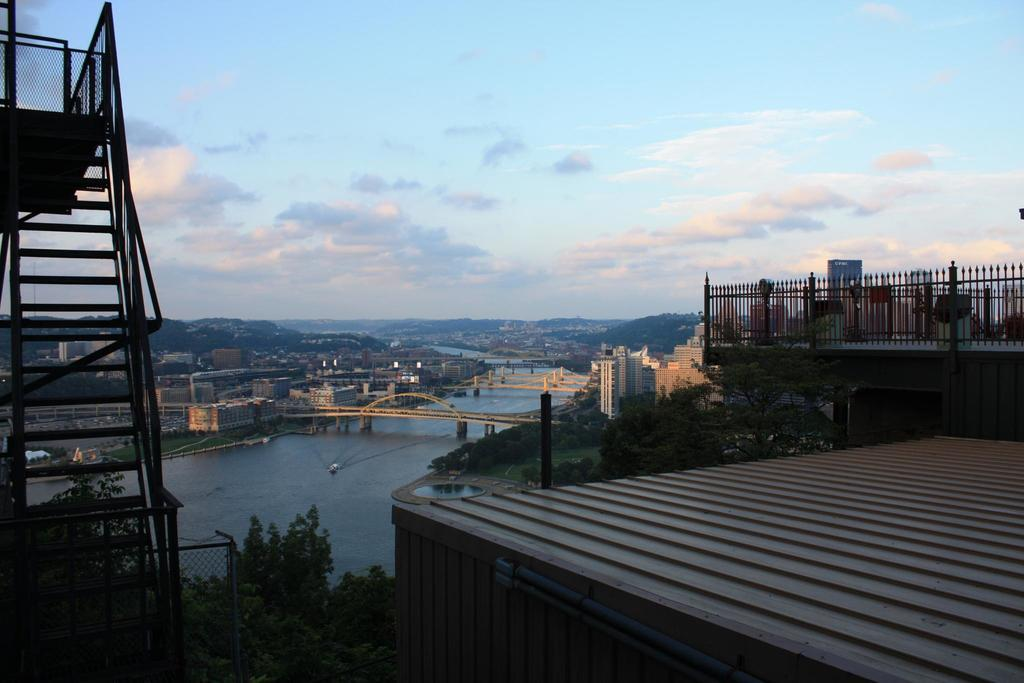What can be seen on the left side of the image? There are stairs on the left side of the image. What structures are visible in the image? There are poles and a bridge visible in the image. What type of vegetation is present in the image? There are trees with green color in the image. What natural element is present in the image? There is water in the image. What can be seen in the sky in the image? The sky is visible in the image, with blue and white colors. Where is the father standing with his crayons in the image? There is no father or crayons present in the image. How many cows can be seen grazing near the water in the image? There are no cows present in the image. 